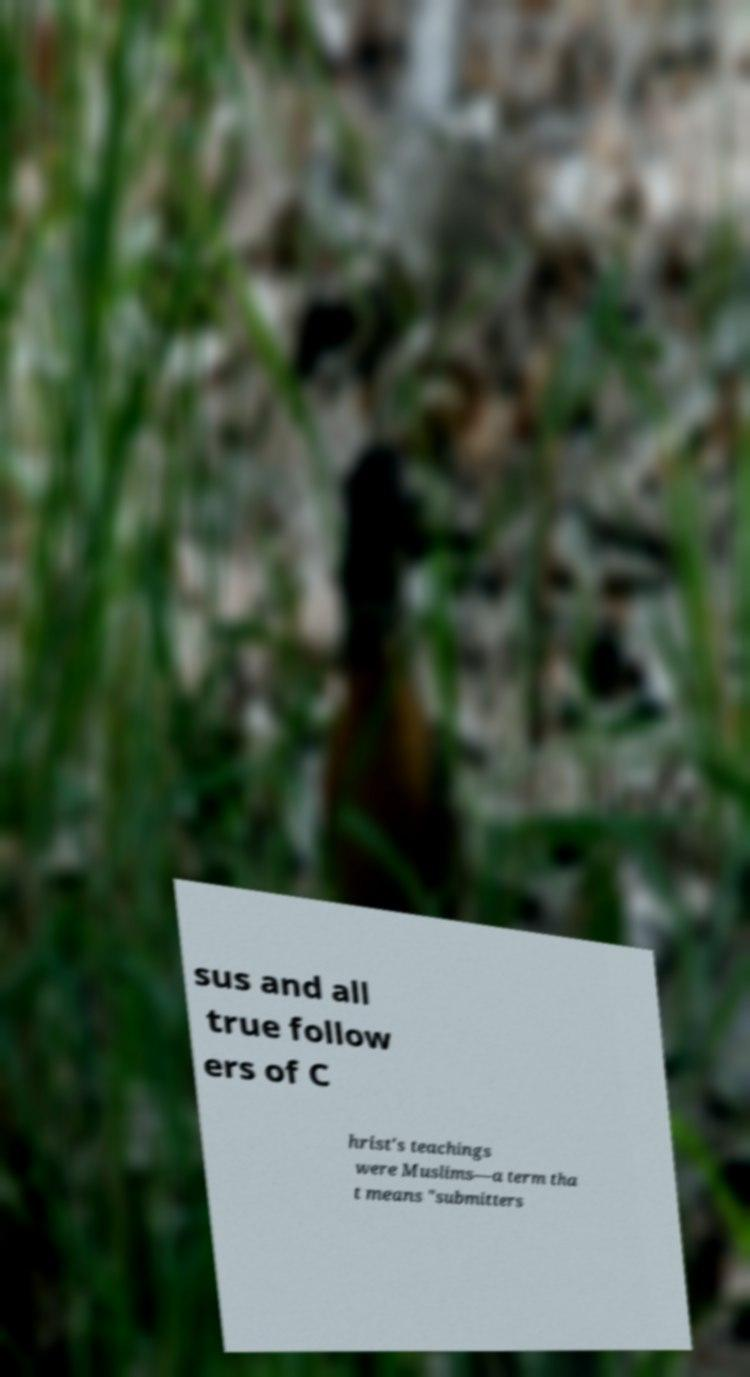There's text embedded in this image that I need extracted. Can you transcribe it verbatim? sus and all true follow ers of C hrist's teachings were Muslims—a term tha t means "submitters 